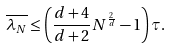Convert formula to latex. <formula><loc_0><loc_0><loc_500><loc_500>\overline { \lambda _ { N } } \leq \left ( \frac { d + 4 } { d + 2 } N ^ { \frac { 2 } { d } } - 1 \right ) \tau .</formula> 